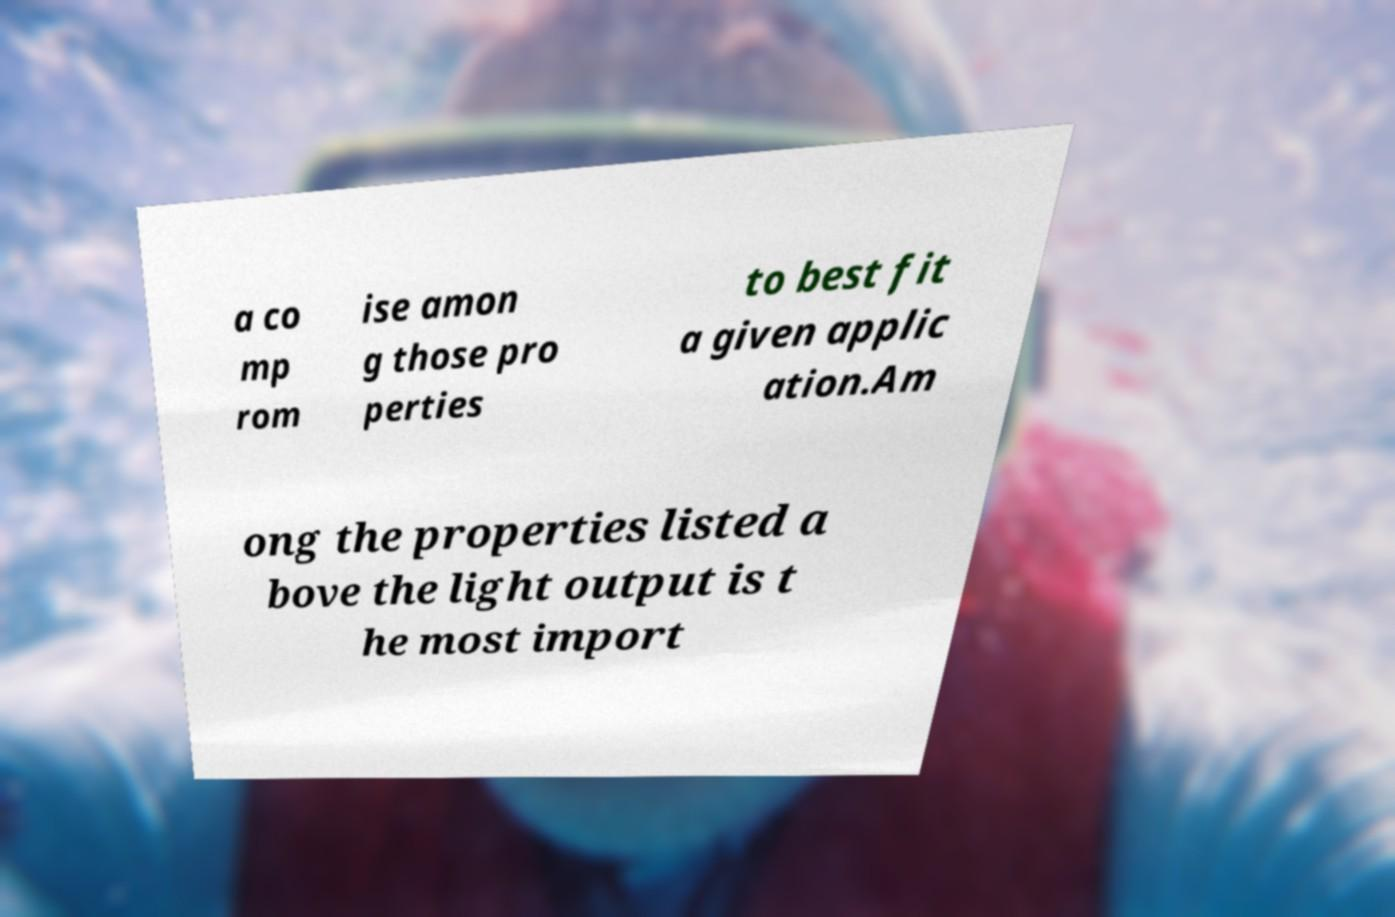Please identify and transcribe the text found in this image. a co mp rom ise amon g those pro perties to best fit a given applic ation.Am ong the properties listed a bove the light output is t he most import 